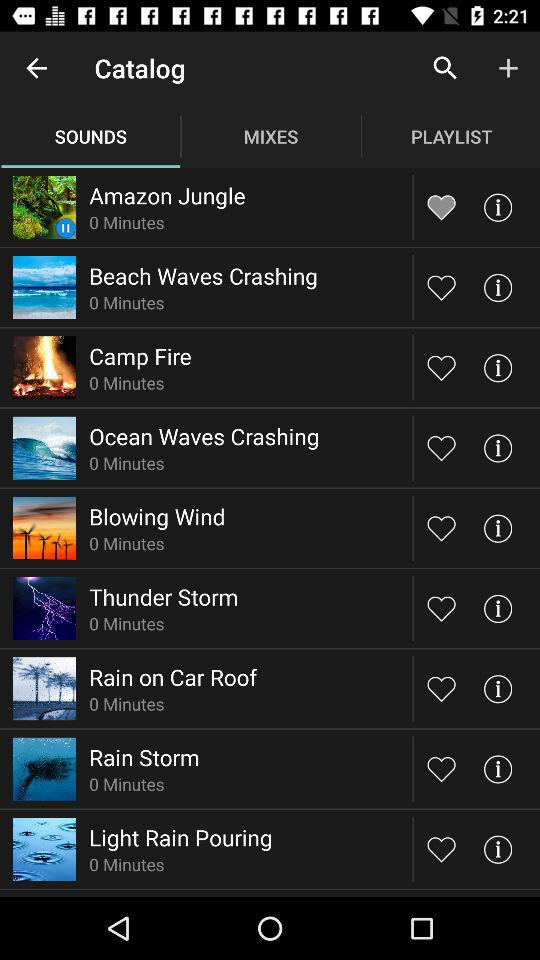How many sound effects are in the catalog?
Answer the question using a single word or phrase. 9 